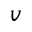<formula> <loc_0><loc_0><loc_500><loc_500>v</formula> 